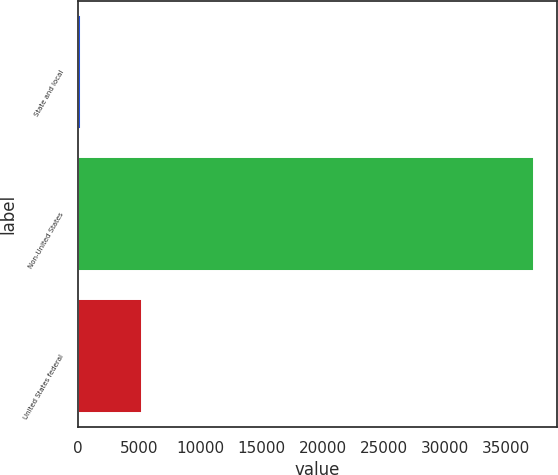Convert chart to OTSL. <chart><loc_0><loc_0><loc_500><loc_500><bar_chart><fcel>State and local<fcel>Non-United States<fcel>United States federal<nl><fcel>247<fcel>37270<fcel>5249<nl></chart> 